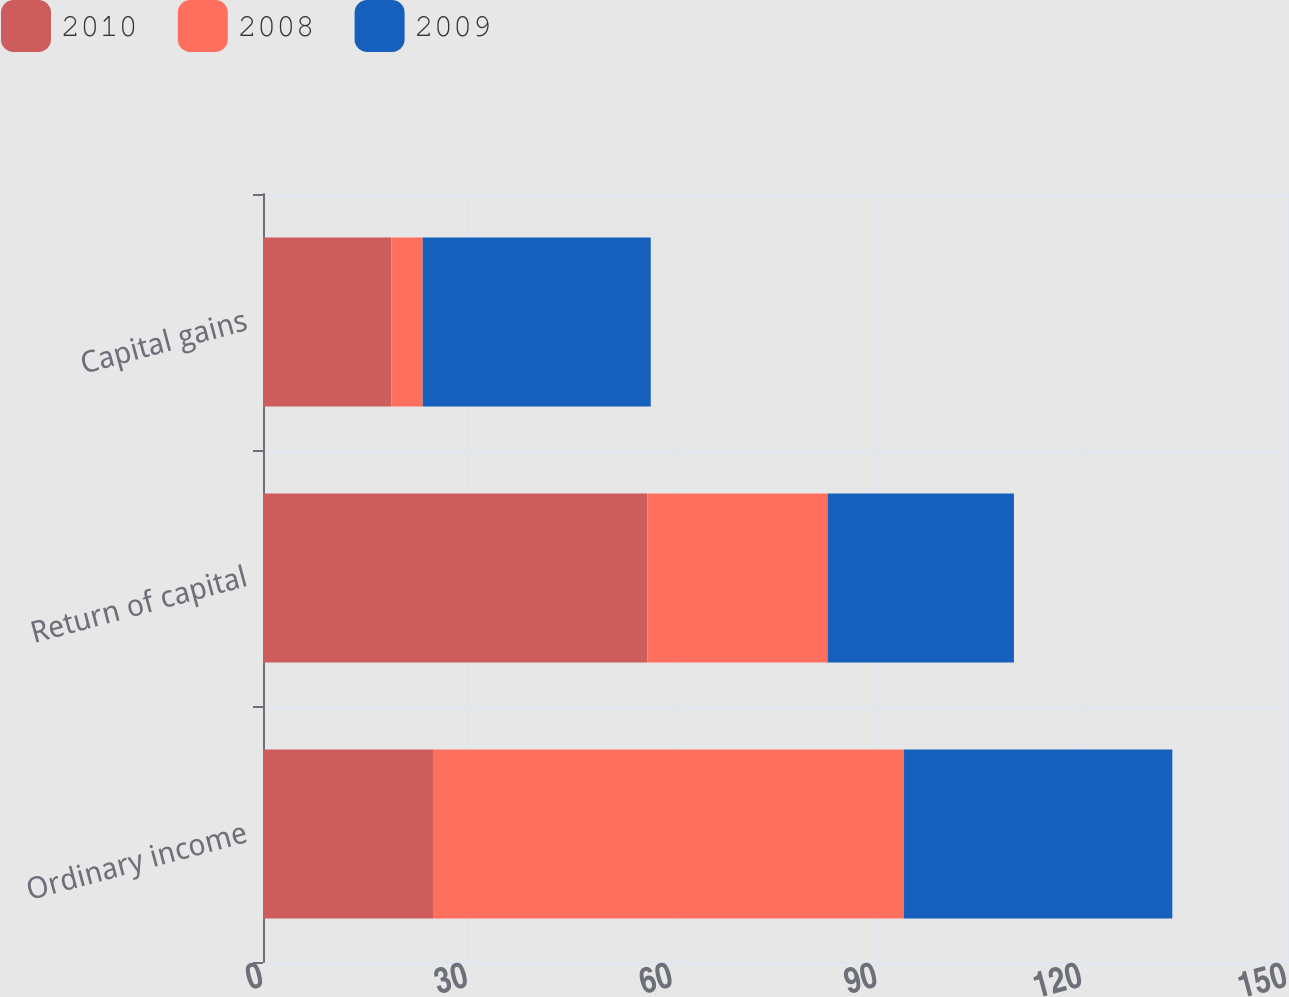<chart> <loc_0><loc_0><loc_500><loc_500><stacked_bar_chart><ecel><fcel>Ordinary income<fcel>Return of capital<fcel>Capital gains<nl><fcel>2010<fcel>24.9<fcel>56.3<fcel>18.8<nl><fcel>2008<fcel>69<fcel>26.4<fcel>4.6<nl><fcel>2009<fcel>39.3<fcel>27.3<fcel>33.4<nl></chart> 